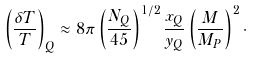<formula> <loc_0><loc_0><loc_500><loc_500>\left ( \frac { \delta T } { T } \right ) _ { Q } \approx 8 \pi \left ( \frac { N _ { Q } } { 4 5 } \right ) ^ { 1 / 2 } \frac { x _ { Q } } { y _ { Q } } \left ( \frac { M } { M _ { P } } \right ) ^ { 2 } \cdot</formula> 